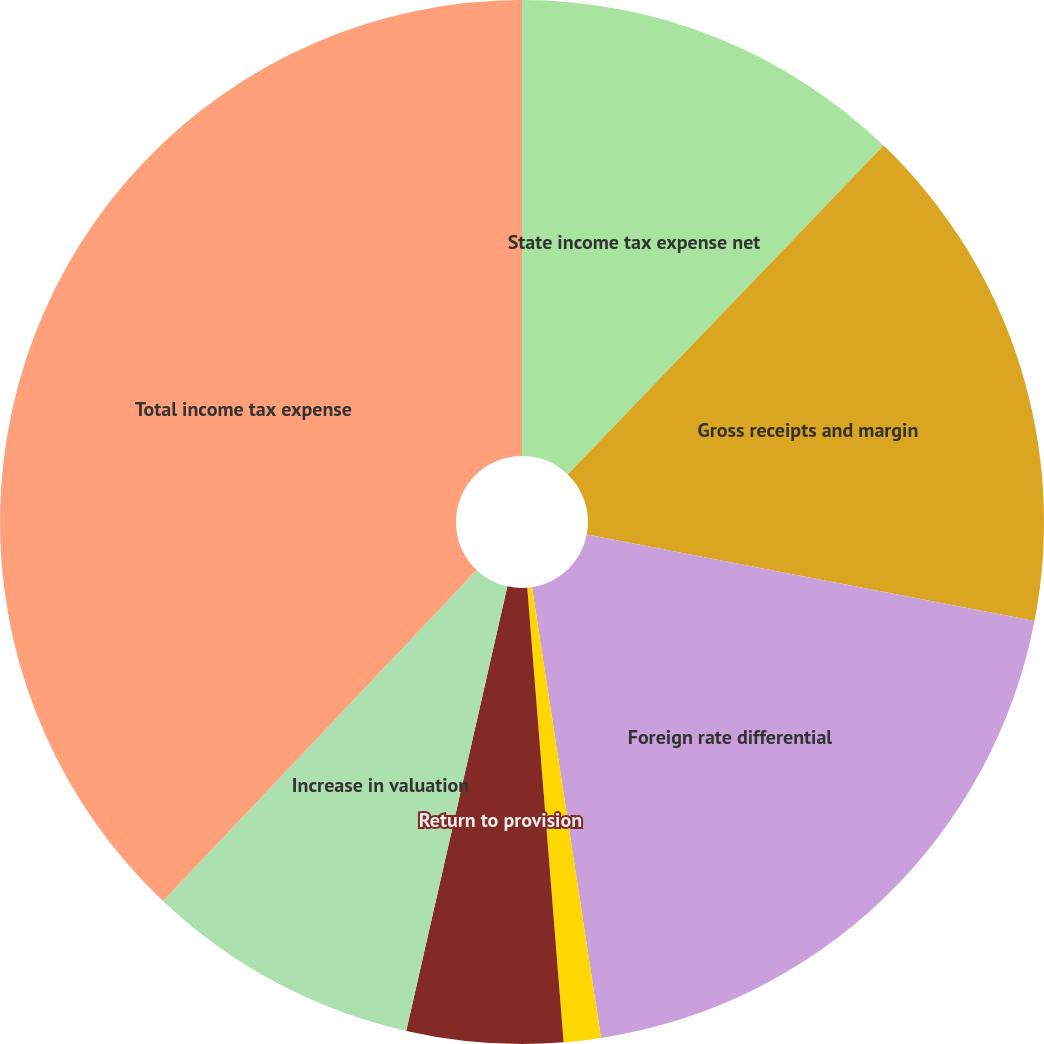Convert chart. <chart><loc_0><loc_0><loc_500><loc_500><pie_chart><fcel>State income tax expense net<fcel>Gross receipts and margin<fcel>Foreign rate differential<fcel>Effect of permanent<fcel>Return to provision<fcel>Increase in valuation<fcel>Total income tax expense<nl><fcel>12.18%<fcel>15.86%<fcel>19.54%<fcel>1.15%<fcel>4.83%<fcel>8.51%<fcel>37.93%<nl></chart> 